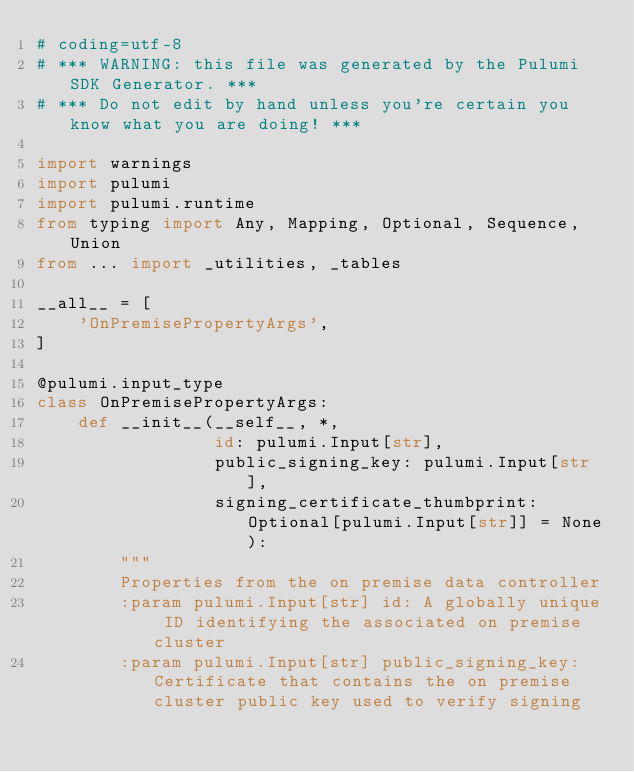Convert code to text. <code><loc_0><loc_0><loc_500><loc_500><_Python_># coding=utf-8
# *** WARNING: this file was generated by the Pulumi SDK Generator. ***
# *** Do not edit by hand unless you're certain you know what you are doing! ***

import warnings
import pulumi
import pulumi.runtime
from typing import Any, Mapping, Optional, Sequence, Union
from ... import _utilities, _tables

__all__ = [
    'OnPremisePropertyArgs',
]

@pulumi.input_type
class OnPremisePropertyArgs:
    def __init__(__self__, *,
                 id: pulumi.Input[str],
                 public_signing_key: pulumi.Input[str],
                 signing_certificate_thumbprint: Optional[pulumi.Input[str]] = None):
        """
        Properties from the on premise data controller
        :param pulumi.Input[str] id: A globally unique ID identifying the associated on premise cluster
        :param pulumi.Input[str] public_signing_key: Certificate that contains the on premise cluster public key used to verify signing</code> 